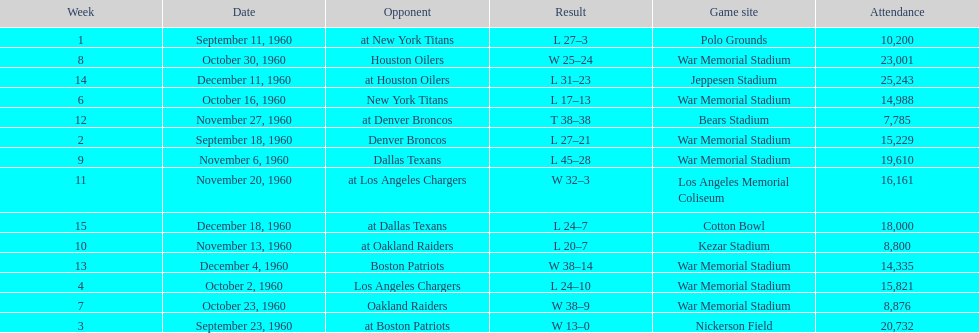How many games had at least 10,000 people in attendance? 11. 